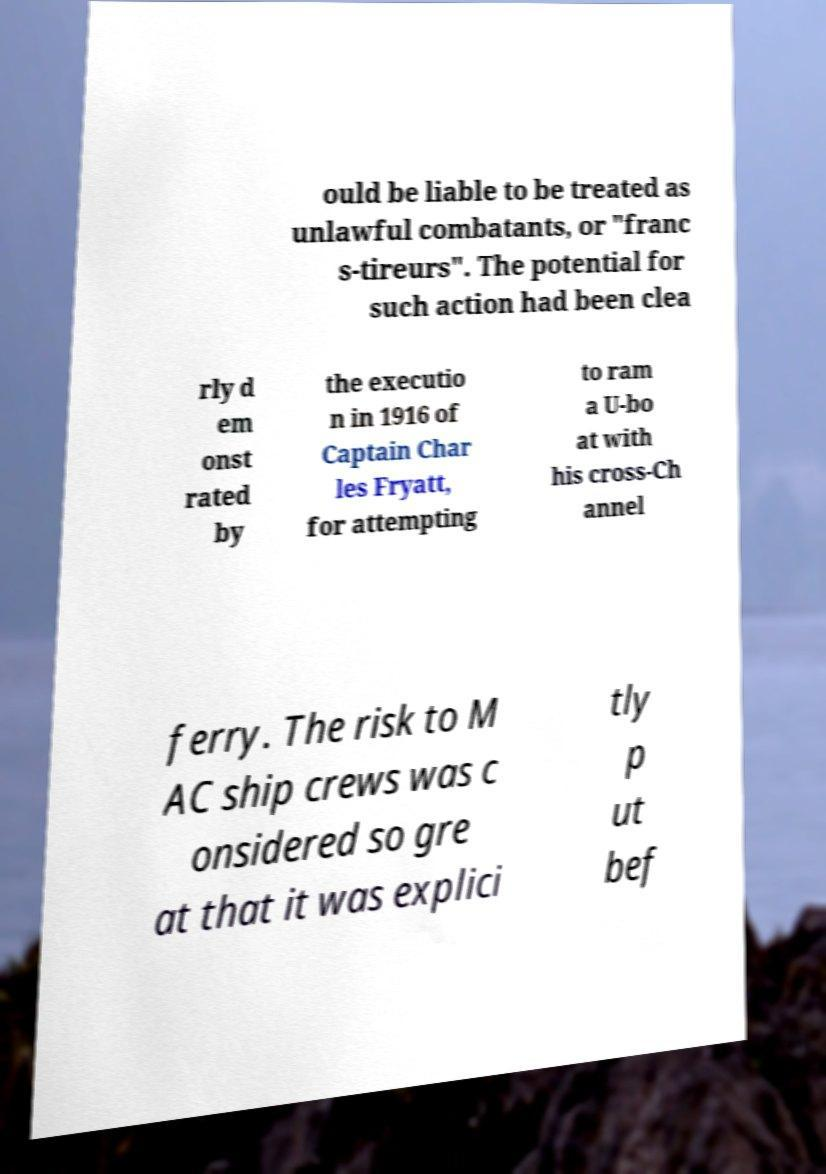Can you accurately transcribe the text from the provided image for me? ould be liable to be treated as unlawful combatants, or "franc s-tireurs". The potential for such action had been clea rly d em onst rated by the executio n in 1916 of Captain Char les Fryatt, for attempting to ram a U-bo at with his cross-Ch annel ferry. The risk to M AC ship crews was c onsidered so gre at that it was explici tly p ut bef 